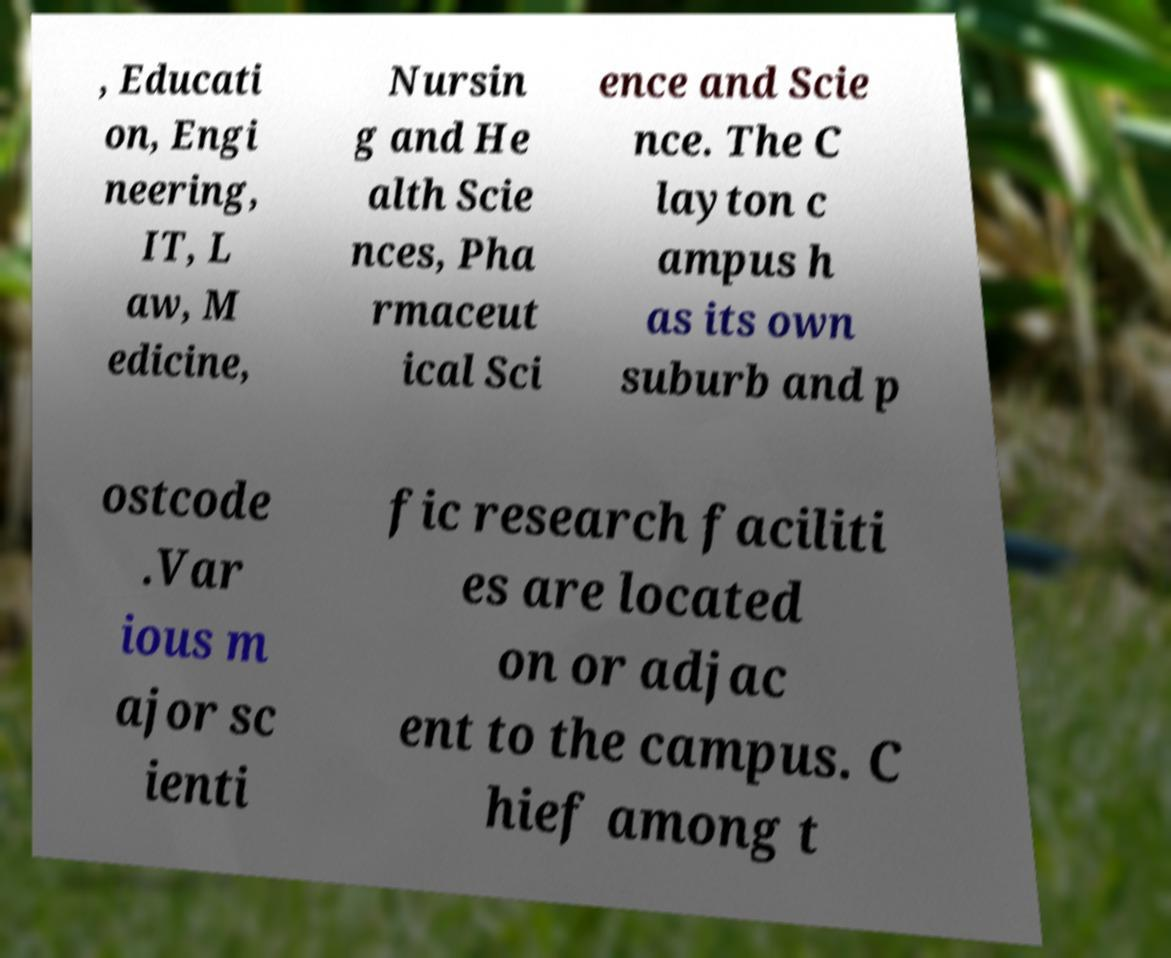Can you accurately transcribe the text from the provided image for me? , Educati on, Engi neering, IT, L aw, M edicine, Nursin g and He alth Scie nces, Pha rmaceut ical Sci ence and Scie nce. The C layton c ampus h as its own suburb and p ostcode .Var ious m ajor sc ienti fic research faciliti es are located on or adjac ent to the campus. C hief among t 